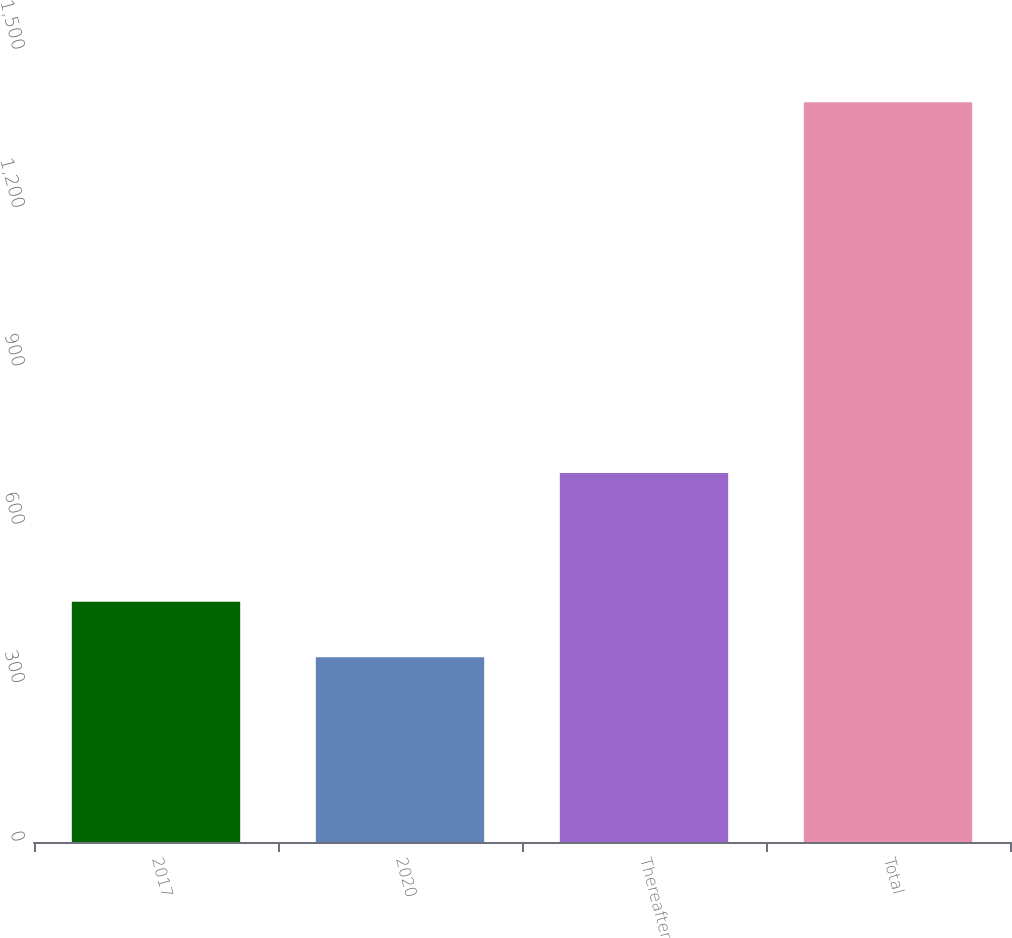<chart> <loc_0><loc_0><loc_500><loc_500><bar_chart><fcel>2017<fcel>2020<fcel>Thereafter<fcel>Total<nl><fcel>455.03<fcel>349.9<fcel>698.9<fcel>1401.2<nl></chart> 